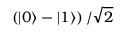Convert formula to latex. <formula><loc_0><loc_0><loc_500><loc_500>\left ( \left | 0 \right \rangle - \left | 1 \right \rangle \right ) / { \sqrt { 2 } }</formula> 